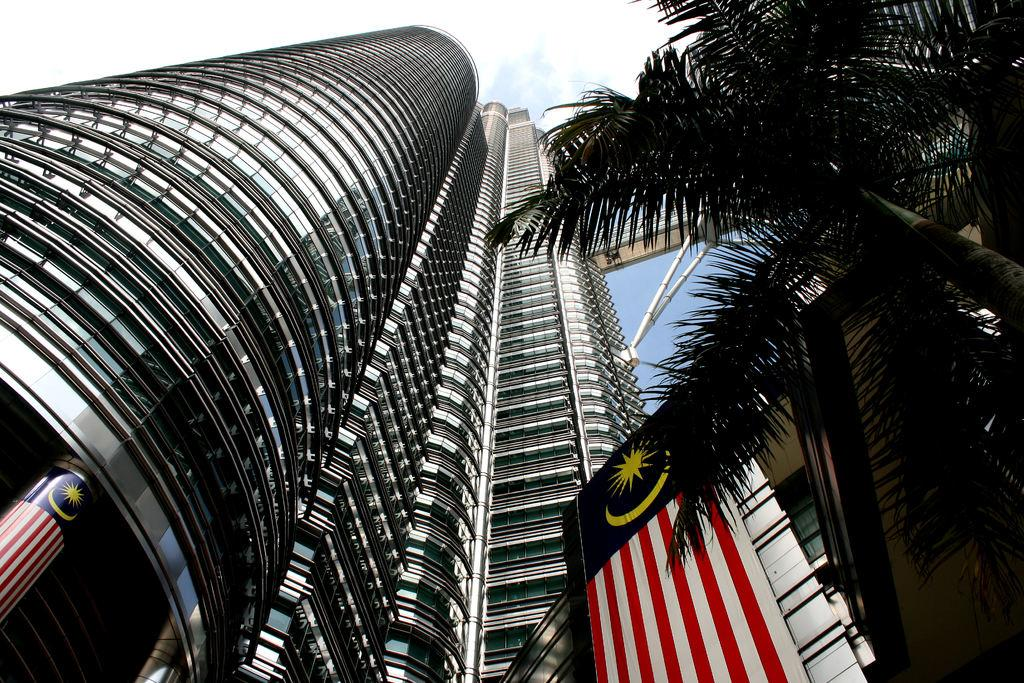What structure is the main subject of the image? There is a building in the image. What can be seen on the right side of the image? There is a tree and a flag on the right side of the image. What objects are visible in the background of the image? There are poles visible in the background of the image. What is visible in the sky in the image? The sky is visible in the background of the image. What level of pollution can be observed in the image? There is no indication of pollution in the image; it only shows a building, a tree, a flag, poles, and the sky. Can you tell me when the birth of the tree in the image occurred? The image does not provide information about the birth of the tree; it only shows the tree as it appears in the present moment. 